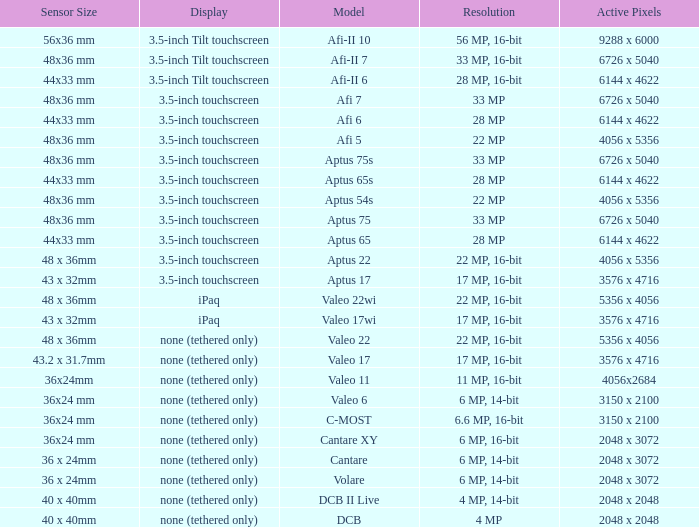Can you parse all the data within this table? {'header': ['Sensor Size', 'Display', 'Model', 'Resolution', 'Active Pixels'], 'rows': [['56x36 mm', '3.5-inch Tilt touchscreen', 'Afi-II 10', '56 MP, 16-bit', '9288 x 6000'], ['48x36 mm', '3.5-inch Tilt touchscreen', 'Afi-II 7', '33 MP, 16-bit', '6726 x 5040'], ['44x33 mm', '3.5-inch Tilt touchscreen', 'Afi-II 6', '28 MP, 16-bit', '6144 x 4622'], ['48x36 mm', '3.5-inch touchscreen', 'Afi 7', '33 MP', '6726 x 5040'], ['44x33 mm', '3.5-inch touchscreen', 'Afi 6', '28 MP', '6144 x 4622'], ['48x36 mm', '3.5-inch touchscreen', 'Afi 5', '22 MP', '4056 x 5356'], ['48x36 mm', '3.5-inch touchscreen', 'Aptus 75s', '33 MP', '6726 x 5040'], ['44x33 mm', '3.5-inch touchscreen', 'Aptus 65s', '28 MP', '6144 x 4622'], ['48x36 mm', '3.5-inch touchscreen', 'Aptus 54s', '22 MP', '4056 x 5356'], ['48x36 mm', '3.5-inch touchscreen', 'Aptus 75', '33 MP', '6726 x 5040'], ['44x33 mm', '3.5-inch touchscreen', 'Aptus 65', '28 MP', '6144 x 4622'], ['48 x 36mm', '3.5-inch touchscreen', 'Aptus 22', '22 MP, 16-bit', '4056 x 5356'], ['43 x 32mm', '3.5-inch touchscreen', 'Aptus 17', '17 MP, 16-bit', '3576 x 4716'], ['48 x 36mm', 'iPaq', 'Valeo 22wi', '22 MP, 16-bit', '5356 x 4056'], ['43 x 32mm', 'iPaq', 'Valeo 17wi', '17 MP, 16-bit', '3576 x 4716'], ['48 x 36mm', 'none (tethered only)', 'Valeo 22', '22 MP, 16-bit', '5356 x 4056'], ['43.2 x 31.7mm', 'none (tethered only)', 'Valeo 17', '17 MP, 16-bit', '3576 x 4716'], ['36x24mm', 'none (tethered only)', 'Valeo 11', '11 MP, 16-bit', '4056x2684'], ['36x24 mm', 'none (tethered only)', 'Valeo 6', '6 MP, 14-bit', '3150 x 2100'], ['36x24 mm', 'none (tethered only)', 'C-MOST', '6.6 MP, 16-bit', '3150 x 2100'], ['36x24 mm', 'none (tethered only)', 'Cantare XY', '6 MP, 16-bit', '2048 x 3072'], ['36 x 24mm', 'none (tethered only)', 'Cantare', '6 MP, 14-bit', '2048 x 3072'], ['36 x 24mm', 'none (tethered only)', 'Volare', '6 MP, 14-bit', '2048 x 3072'], ['40 x 40mm', 'none (tethered only)', 'DCB II Live', '4 MP, 14-bit', '2048 x 2048'], ['40 x 40mm', 'none (tethered only)', 'DCB', '4 MP', '2048 x 2048']]} What are the functioning pixels of the c-most model camera? 3150 x 2100. 